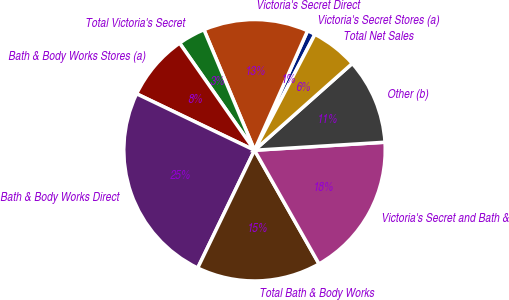Convert chart. <chart><loc_0><loc_0><loc_500><loc_500><pie_chart><fcel>Victoria's Secret Stores (a)<fcel>Victoria's Secret Direct<fcel>Total Victoria's Secret<fcel>Bath & Body Works Stores (a)<fcel>Bath & Body Works Direct<fcel>Total Bath & Body Works<fcel>Victoria's Secret and Bath &<fcel>Other (b)<fcel>Total Net Sales<nl><fcel>1.0%<fcel>12.97%<fcel>3.39%<fcel>8.18%<fcel>24.95%<fcel>15.37%<fcel>17.76%<fcel>10.58%<fcel>5.79%<nl></chart> 